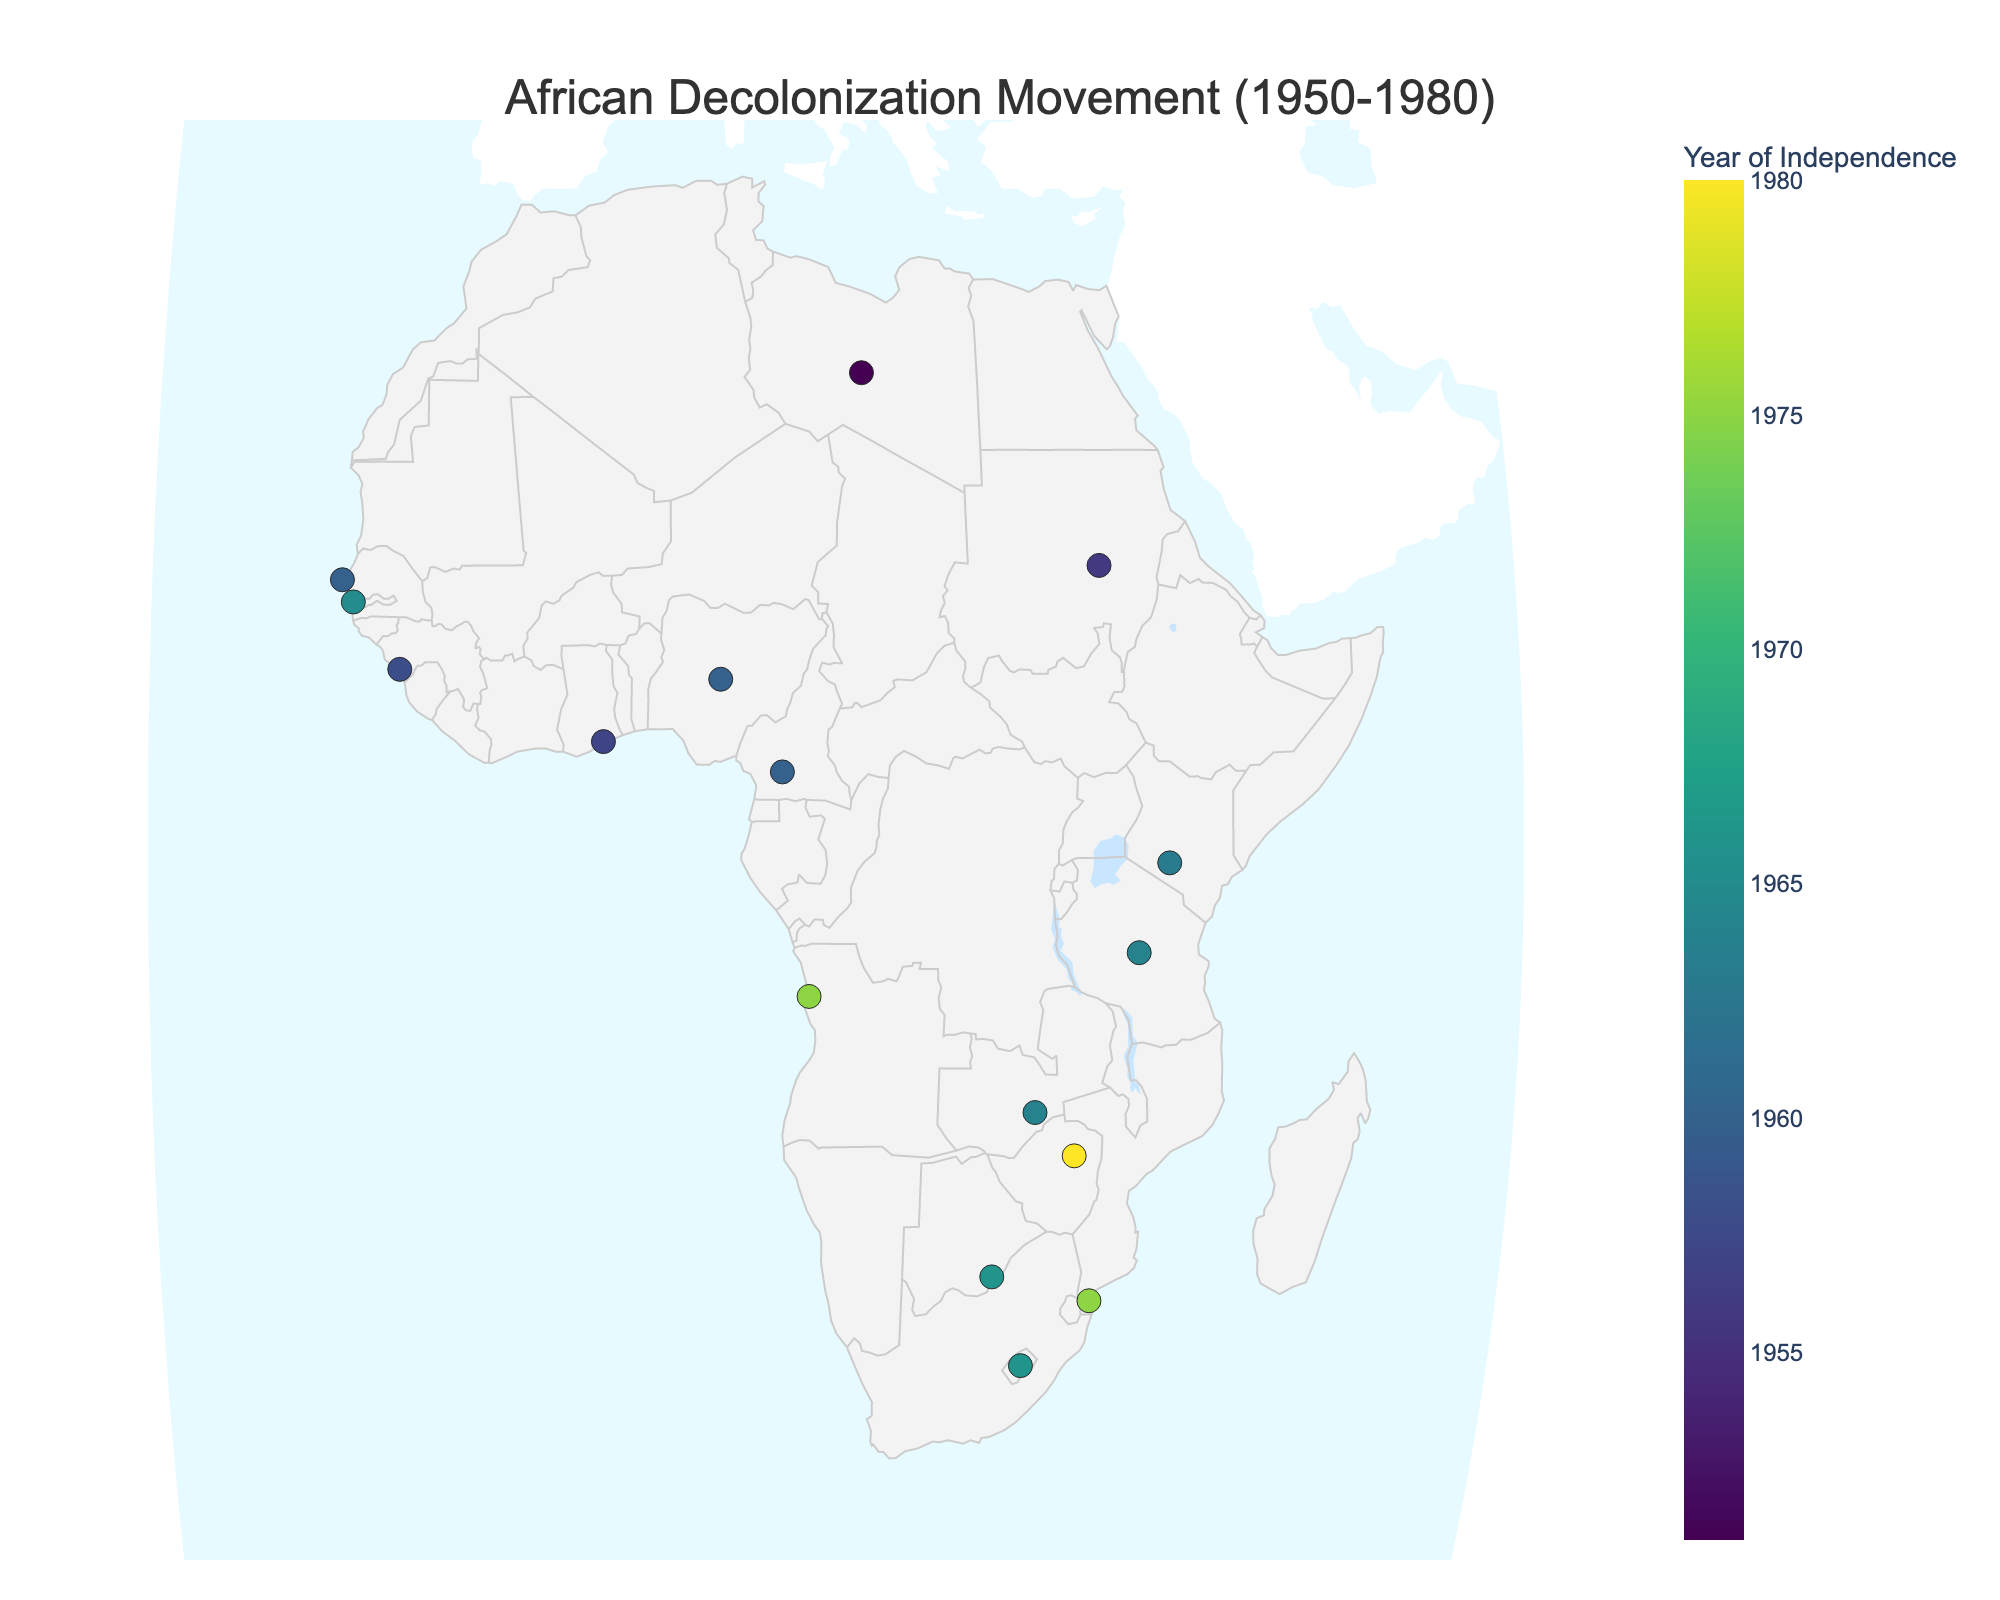Which country gained independence earliest in the period 1950-1980? Look for the country with the earliest year in the data points. Libya gained independence in 1951.
Answer: Libya Which country is last shown to gain independence? Identify the country with the latest year in the data points. Zimbabwe gained independence in 1980.
Answer: Zimbabwe How many countries gained independence in 1960? Count the number of markers on the map with the year 1960. Cameroon, Senegal, and Nigeria all gained independence in 1960. There are three countries.
Answer: 3 Does Mozambique gain independence before or after Angola? Compare the independence years of Mozambique and Angola. Mozambique and Angola both gain independence in 1975.
Answer: Same year What is the average year of independence for the countries shown? Sum the independence years and divide by the number of countries. The sum is 197,435 and there are 16 countries, so 197,435 / 16 = 1973.44.
Answer: 1973 Which countries gained independence after 1970? Identify the countries with independence years after 1970. Angola (1975), Mozambique (1975), and Zimbabwe (1980).
Answer: Angola, Mozambique, Zimbabwe Is there a visible trend in the progression of independence across Africa? Look at the distribution of the independence years across the map. The independence movements spread from Northwest Africa in the 1950s to Southern Africa in the 1960s-1980s.
Answer: Independence moved generally southward Which country located farthest south gained independence in 1966? Identify the latitude of the countries that gained independence in 1966. Botswana (-24.6282) and Lesotho (-29.6100) gained independence in 1966. Lesotho is farther south.
Answer: Lesotho How does the range of independence years affect the colors of the markers? Examine the color scale based on the independence years. Earlier years are shown in cooler colors, while later years are indicated with warmer colors on the map.
Answer: Cooler for earlier, warmer for later Which country is displayed closest to the equator? Identify the country with a latitude closest to zero. Based on the provided data, Kenya has a latitude of -1.2921, which is closest to the equator.
Answer: Kenya 